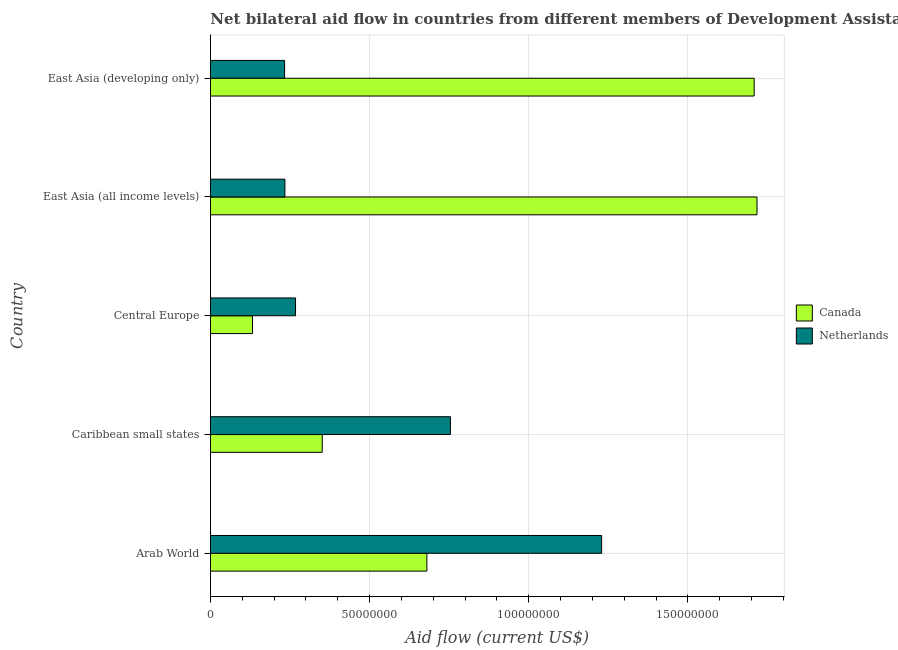How many different coloured bars are there?
Offer a very short reply. 2. How many bars are there on the 3rd tick from the top?
Provide a succinct answer. 2. How many bars are there on the 3rd tick from the bottom?
Offer a very short reply. 2. What is the label of the 2nd group of bars from the top?
Offer a very short reply. East Asia (all income levels). In how many cases, is the number of bars for a given country not equal to the number of legend labels?
Your answer should be very brief. 0. What is the amount of aid given by netherlands in Arab World?
Offer a terse response. 1.23e+08. Across all countries, what is the maximum amount of aid given by netherlands?
Ensure brevity in your answer.  1.23e+08. Across all countries, what is the minimum amount of aid given by netherlands?
Provide a short and direct response. 2.33e+07. In which country was the amount of aid given by canada maximum?
Your response must be concise. East Asia (all income levels). In which country was the amount of aid given by netherlands minimum?
Give a very brief answer. East Asia (developing only). What is the total amount of aid given by netherlands in the graph?
Your answer should be very brief. 2.72e+08. What is the difference between the amount of aid given by netherlands in Arab World and that in East Asia (all income levels)?
Offer a terse response. 9.95e+07. What is the difference between the amount of aid given by canada in East Asia (developing only) and the amount of aid given by netherlands in Arab World?
Offer a terse response. 4.79e+07. What is the average amount of aid given by netherlands per country?
Give a very brief answer. 5.43e+07. What is the difference between the amount of aid given by canada and amount of aid given by netherlands in Caribbean small states?
Give a very brief answer. -4.03e+07. In how many countries, is the amount of aid given by canada greater than 10000000 US$?
Give a very brief answer. 5. What is the ratio of the amount of aid given by canada in Arab World to that in East Asia (all income levels)?
Make the answer very short. 0.4. Is the amount of aid given by netherlands in Caribbean small states less than that in Central Europe?
Provide a short and direct response. No. Is the difference between the amount of aid given by canada in Arab World and Central Europe greater than the difference between the amount of aid given by netherlands in Arab World and Central Europe?
Your answer should be very brief. No. What is the difference between the highest and the second highest amount of aid given by netherlands?
Give a very brief answer. 4.75e+07. What is the difference between the highest and the lowest amount of aid given by canada?
Keep it short and to the point. 1.58e+08. In how many countries, is the amount of aid given by canada greater than the average amount of aid given by canada taken over all countries?
Offer a very short reply. 2. What does the 2nd bar from the bottom in Arab World represents?
Make the answer very short. Netherlands. How many countries are there in the graph?
Make the answer very short. 5. What is the difference between two consecutive major ticks on the X-axis?
Your response must be concise. 5.00e+07. Are the values on the major ticks of X-axis written in scientific E-notation?
Your response must be concise. No. Where does the legend appear in the graph?
Your answer should be very brief. Center right. How many legend labels are there?
Your answer should be compact. 2. How are the legend labels stacked?
Make the answer very short. Vertical. What is the title of the graph?
Provide a short and direct response. Net bilateral aid flow in countries from different members of Development Assistance Committee. Does "Male" appear as one of the legend labels in the graph?
Ensure brevity in your answer.  No. What is the label or title of the X-axis?
Offer a terse response. Aid flow (current US$). What is the label or title of the Y-axis?
Your response must be concise. Country. What is the Aid flow (current US$) in Canada in Arab World?
Your answer should be compact. 6.80e+07. What is the Aid flow (current US$) of Netherlands in Arab World?
Offer a terse response. 1.23e+08. What is the Aid flow (current US$) of Canada in Caribbean small states?
Ensure brevity in your answer.  3.51e+07. What is the Aid flow (current US$) in Netherlands in Caribbean small states?
Give a very brief answer. 7.54e+07. What is the Aid flow (current US$) in Canada in Central Europe?
Your answer should be very brief. 1.32e+07. What is the Aid flow (current US$) in Netherlands in Central Europe?
Your response must be concise. 2.67e+07. What is the Aid flow (current US$) of Canada in East Asia (all income levels)?
Provide a succinct answer. 1.72e+08. What is the Aid flow (current US$) of Netherlands in East Asia (all income levels)?
Make the answer very short. 2.34e+07. What is the Aid flow (current US$) of Canada in East Asia (developing only)?
Your answer should be compact. 1.71e+08. What is the Aid flow (current US$) of Netherlands in East Asia (developing only)?
Ensure brevity in your answer.  2.33e+07. Across all countries, what is the maximum Aid flow (current US$) in Canada?
Offer a terse response. 1.72e+08. Across all countries, what is the maximum Aid flow (current US$) in Netherlands?
Your answer should be very brief. 1.23e+08. Across all countries, what is the minimum Aid flow (current US$) of Canada?
Offer a terse response. 1.32e+07. Across all countries, what is the minimum Aid flow (current US$) of Netherlands?
Ensure brevity in your answer.  2.33e+07. What is the total Aid flow (current US$) in Canada in the graph?
Provide a succinct answer. 4.59e+08. What is the total Aid flow (current US$) in Netherlands in the graph?
Ensure brevity in your answer.  2.72e+08. What is the difference between the Aid flow (current US$) of Canada in Arab World and that in Caribbean small states?
Your response must be concise. 3.29e+07. What is the difference between the Aid flow (current US$) of Netherlands in Arab World and that in Caribbean small states?
Offer a terse response. 4.75e+07. What is the difference between the Aid flow (current US$) in Canada in Arab World and that in Central Europe?
Your answer should be compact. 5.48e+07. What is the difference between the Aid flow (current US$) of Netherlands in Arab World and that in Central Europe?
Keep it short and to the point. 9.62e+07. What is the difference between the Aid flow (current US$) in Canada in Arab World and that in East Asia (all income levels)?
Offer a very short reply. -1.04e+08. What is the difference between the Aid flow (current US$) of Netherlands in Arab World and that in East Asia (all income levels)?
Your answer should be compact. 9.95e+07. What is the difference between the Aid flow (current US$) of Canada in Arab World and that in East Asia (developing only)?
Your response must be concise. -1.03e+08. What is the difference between the Aid flow (current US$) of Netherlands in Arab World and that in East Asia (developing only)?
Keep it short and to the point. 9.96e+07. What is the difference between the Aid flow (current US$) of Canada in Caribbean small states and that in Central Europe?
Give a very brief answer. 2.19e+07. What is the difference between the Aid flow (current US$) of Netherlands in Caribbean small states and that in Central Europe?
Offer a terse response. 4.87e+07. What is the difference between the Aid flow (current US$) of Canada in Caribbean small states and that in East Asia (all income levels)?
Your answer should be very brief. -1.37e+08. What is the difference between the Aid flow (current US$) of Netherlands in Caribbean small states and that in East Asia (all income levels)?
Provide a short and direct response. 5.20e+07. What is the difference between the Aid flow (current US$) in Canada in Caribbean small states and that in East Asia (developing only)?
Make the answer very short. -1.36e+08. What is the difference between the Aid flow (current US$) of Netherlands in Caribbean small states and that in East Asia (developing only)?
Give a very brief answer. 5.21e+07. What is the difference between the Aid flow (current US$) of Canada in Central Europe and that in East Asia (all income levels)?
Provide a short and direct response. -1.58e+08. What is the difference between the Aid flow (current US$) in Netherlands in Central Europe and that in East Asia (all income levels)?
Keep it short and to the point. 3.34e+06. What is the difference between the Aid flow (current US$) in Canada in Central Europe and that in East Asia (developing only)?
Your answer should be very brief. -1.58e+08. What is the difference between the Aid flow (current US$) in Netherlands in Central Europe and that in East Asia (developing only)?
Offer a terse response. 3.44e+06. What is the difference between the Aid flow (current US$) of Canada in East Asia (all income levels) and that in East Asia (developing only)?
Make the answer very short. 8.80e+05. What is the difference between the Aid flow (current US$) in Canada in Arab World and the Aid flow (current US$) in Netherlands in Caribbean small states?
Provide a short and direct response. -7.40e+06. What is the difference between the Aid flow (current US$) in Canada in Arab World and the Aid flow (current US$) in Netherlands in Central Europe?
Provide a short and direct response. 4.13e+07. What is the difference between the Aid flow (current US$) in Canada in Arab World and the Aid flow (current US$) in Netherlands in East Asia (all income levels)?
Keep it short and to the point. 4.46e+07. What is the difference between the Aid flow (current US$) in Canada in Arab World and the Aid flow (current US$) in Netherlands in East Asia (developing only)?
Offer a terse response. 4.47e+07. What is the difference between the Aid flow (current US$) of Canada in Caribbean small states and the Aid flow (current US$) of Netherlands in Central Europe?
Make the answer very short. 8.39e+06. What is the difference between the Aid flow (current US$) in Canada in Caribbean small states and the Aid flow (current US$) in Netherlands in East Asia (all income levels)?
Your response must be concise. 1.17e+07. What is the difference between the Aid flow (current US$) in Canada in Caribbean small states and the Aid flow (current US$) in Netherlands in East Asia (developing only)?
Make the answer very short. 1.18e+07. What is the difference between the Aid flow (current US$) in Canada in Central Europe and the Aid flow (current US$) in Netherlands in East Asia (all income levels)?
Ensure brevity in your answer.  -1.02e+07. What is the difference between the Aid flow (current US$) in Canada in Central Europe and the Aid flow (current US$) in Netherlands in East Asia (developing only)?
Make the answer very short. -1.01e+07. What is the difference between the Aid flow (current US$) in Canada in East Asia (all income levels) and the Aid flow (current US$) in Netherlands in East Asia (developing only)?
Your answer should be compact. 1.48e+08. What is the average Aid flow (current US$) of Canada per country?
Provide a short and direct response. 9.18e+07. What is the average Aid flow (current US$) in Netherlands per country?
Provide a succinct answer. 5.43e+07. What is the difference between the Aid flow (current US$) of Canada and Aid flow (current US$) of Netherlands in Arab World?
Offer a terse response. -5.49e+07. What is the difference between the Aid flow (current US$) in Canada and Aid flow (current US$) in Netherlands in Caribbean small states?
Give a very brief answer. -4.03e+07. What is the difference between the Aid flow (current US$) in Canada and Aid flow (current US$) in Netherlands in Central Europe?
Make the answer very short. -1.35e+07. What is the difference between the Aid flow (current US$) of Canada and Aid flow (current US$) of Netherlands in East Asia (all income levels)?
Your answer should be very brief. 1.48e+08. What is the difference between the Aid flow (current US$) in Canada and Aid flow (current US$) in Netherlands in East Asia (developing only)?
Provide a short and direct response. 1.48e+08. What is the ratio of the Aid flow (current US$) of Canada in Arab World to that in Caribbean small states?
Your answer should be very brief. 1.94. What is the ratio of the Aid flow (current US$) in Netherlands in Arab World to that in Caribbean small states?
Your response must be concise. 1.63. What is the ratio of the Aid flow (current US$) in Canada in Arab World to that in Central Europe?
Offer a terse response. 5.15. What is the ratio of the Aid flow (current US$) of Netherlands in Arab World to that in Central Europe?
Make the answer very short. 4.6. What is the ratio of the Aid flow (current US$) of Canada in Arab World to that in East Asia (all income levels)?
Provide a succinct answer. 0.4. What is the ratio of the Aid flow (current US$) in Netherlands in Arab World to that in East Asia (all income levels)?
Give a very brief answer. 5.26. What is the ratio of the Aid flow (current US$) in Canada in Arab World to that in East Asia (developing only)?
Keep it short and to the point. 0.4. What is the ratio of the Aid flow (current US$) of Netherlands in Arab World to that in East Asia (developing only)?
Provide a short and direct response. 5.28. What is the ratio of the Aid flow (current US$) of Canada in Caribbean small states to that in Central Europe?
Offer a very short reply. 2.66. What is the ratio of the Aid flow (current US$) of Netherlands in Caribbean small states to that in Central Europe?
Your answer should be very brief. 2.82. What is the ratio of the Aid flow (current US$) in Canada in Caribbean small states to that in East Asia (all income levels)?
Your response must be concise. 0.2. What is the ratio of the Aid flow (current US$) of Netherlands in Caribbean small states to that in East Asia (all income levels)?
Offer a terse response. 3.22. What is the ratio of the Aid flow (current US$) in Canada in Caribbean small states to that in East Asia (developing only)?
Keep it short and to the point. 0.21. What is the ratio of the Aid flow (current US$) in Netherlands in Caribbean small states to that in East Asia (developing only)?
Ensure brevity in your answer.  3.24. What is the ratio of the Aid flow (current US$) of Canada in Central Europe to that in East Asia (all income levels)?
Give a very brief answer. 0.08. What is the ratio of the Aid flow (current US$) of Netherlands in Central Europe to that in East Asia (all income levels)?
Your answer should be very brief. 1.14. What is the ratio of the Aid flow (current US$) of Canada in Central Europe to that in East Asia (developing only)?
Provide a succinct answer. 0.08. What is the ratio of the Aid flow (current US$) in Netherlands in Central Europe to that in East Asia (developing only)?
Provide a short and direct response. 1.15. What is the ratio of the Aid flow (current US$) of Netherlands in East Asia (all income levels) to that in East Asia (developing only)?
Provide a succinct answer. 1. What is the difference between the highest and the second highest Aid flow (current US$) of Canada?
Offer a very short reply. 8.80e+05. What is the difference between the highest and the second highest Aid flow (current US$) in Netherlands?
Keep it short and to the point. 4.75e+07. What is the difference between the highest and the lowest Aid flow (current US$) in Canada?
Offer a terse response. 1.58e+08. What is the difference between the highest and the lowest Aid flow (current US$) of Netherlands?
Provide a short and direct response. 9.96e+07. 